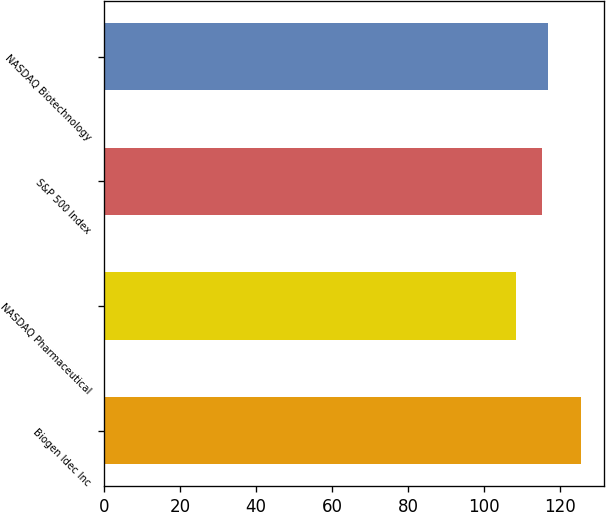Convert chart. <chart><loc_0><loc_0><loc_500><loc_500><bar_chart><fcel>Biogen Idec Inc<fcel>NASDAQ Pharmaceutical<fcel>S&P 500 Index<fcel>NASDAQ Biotechnology<nl><fcel>125.33<fcel>108.4<fcel>115.06<fcel>116.75<nl></chart> 